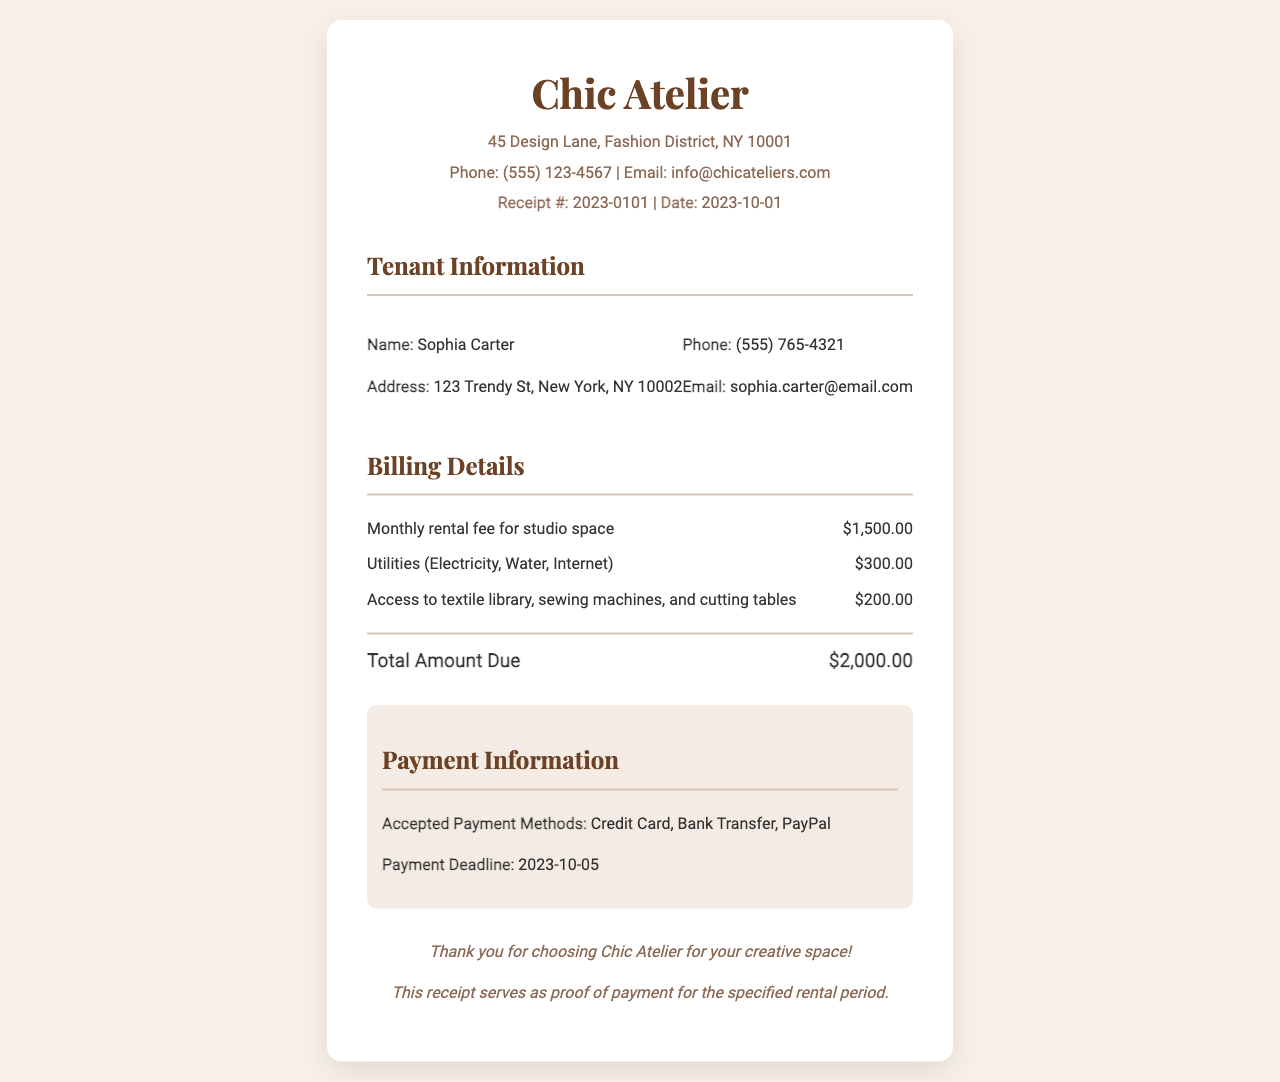What is the name of the tenant? The tenant's name is explicitly listed in the document under Tenant Information.
Answer: Sophia Carter What is the monthly rental fee for studio space? The fee is clearly mentioned in the Billing Details section.
Answer: $1,500.00 When is the payment deadline? The payment deadline is indicated in the Payment Information section.
Answer: 2023-10-05 What is the total amount due? The total amount is calculated based on the itemized billing details in the document.
Answer: $2,000.00 What amenities are included in the design-focused access? The amenities are described in the billing item regarding access to specific resources for designers.
Answer: Access to textile library, sewing machines, and cutting tables What phone number can be used for contacting Chic Atelier? The contact number is provided in the header information of the receipt.
Answer: (555) 123-4567 How much is charged for utilities? The utility charges are listed under the billing details section of the document.
Answer: $300.00 What email address is provided for Chic Atelier? The email address is available in the header section for contact purposes.
Answer: info@chicateliers.com 